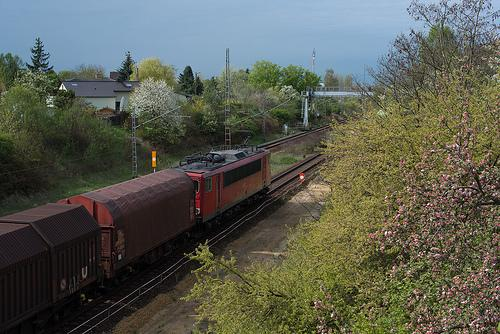Explain the overall content of the image in a single sentence. An old, moving train passes through a picturesque residential neighborhood with green trees and colorful blooms under a clear blue sky. Mention any notable structures present in the image apart from the train. There is a small tower-like structure, a walking bridge over the train tracks, and a white house near the tracks. How many sets of train tracks are visible in the image? There are two sets of train tracks visible in the image. Provide a brief description of the image using the main objects present in the scene. An old, rusty train is moving on the tracks through a residential neighborhood with a white house and green trees. The sky is clear, and colorful leaves are growing along the landscape. What kind of environment is the train moving through? The train is moving through a residential neighborhood surrounded by green trees. Rate the image quality from 1 to 5, with 5 being the best. Considering the clarity and the composition, I would rate the image quality as 4 out of 5. What is the condition of the train and what colors are present on its cars? The train is rusty and old, and it has red train cars. Describe the type of trees and their surrounding aspects in the image. There are white flowering trees, pine trees, and pink flowering trees surrounded by colorful leaves and blooming bushes. What is the atmosphere present in the image? The image has a serene and peaceful atmosphere with a clear sky, green trees, and springtime blooms. In which season does this image likely takes place? The image was likely taken during the spring season, as trees are blooming with flowers. 